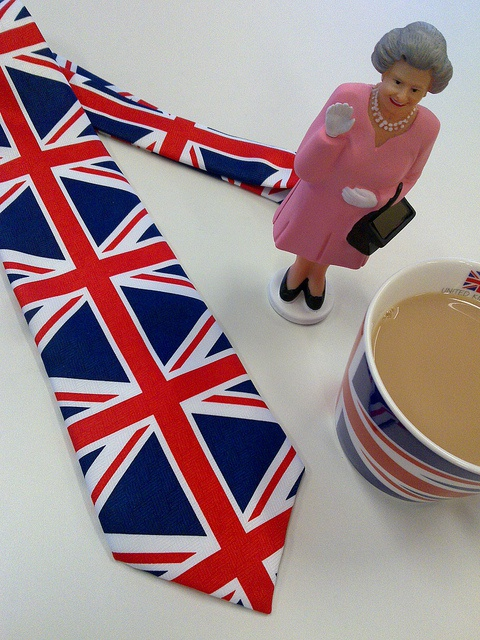Describe the objects in this image and their specific colors. I can see tie in blue, brown, navy, and lightgray tones, cup in blue, gray, tan, and darkgray tones, people in blue, brown, black, gray, and maroon tones, and handbag in blue, black, brown, and lightgray tones in this image. 